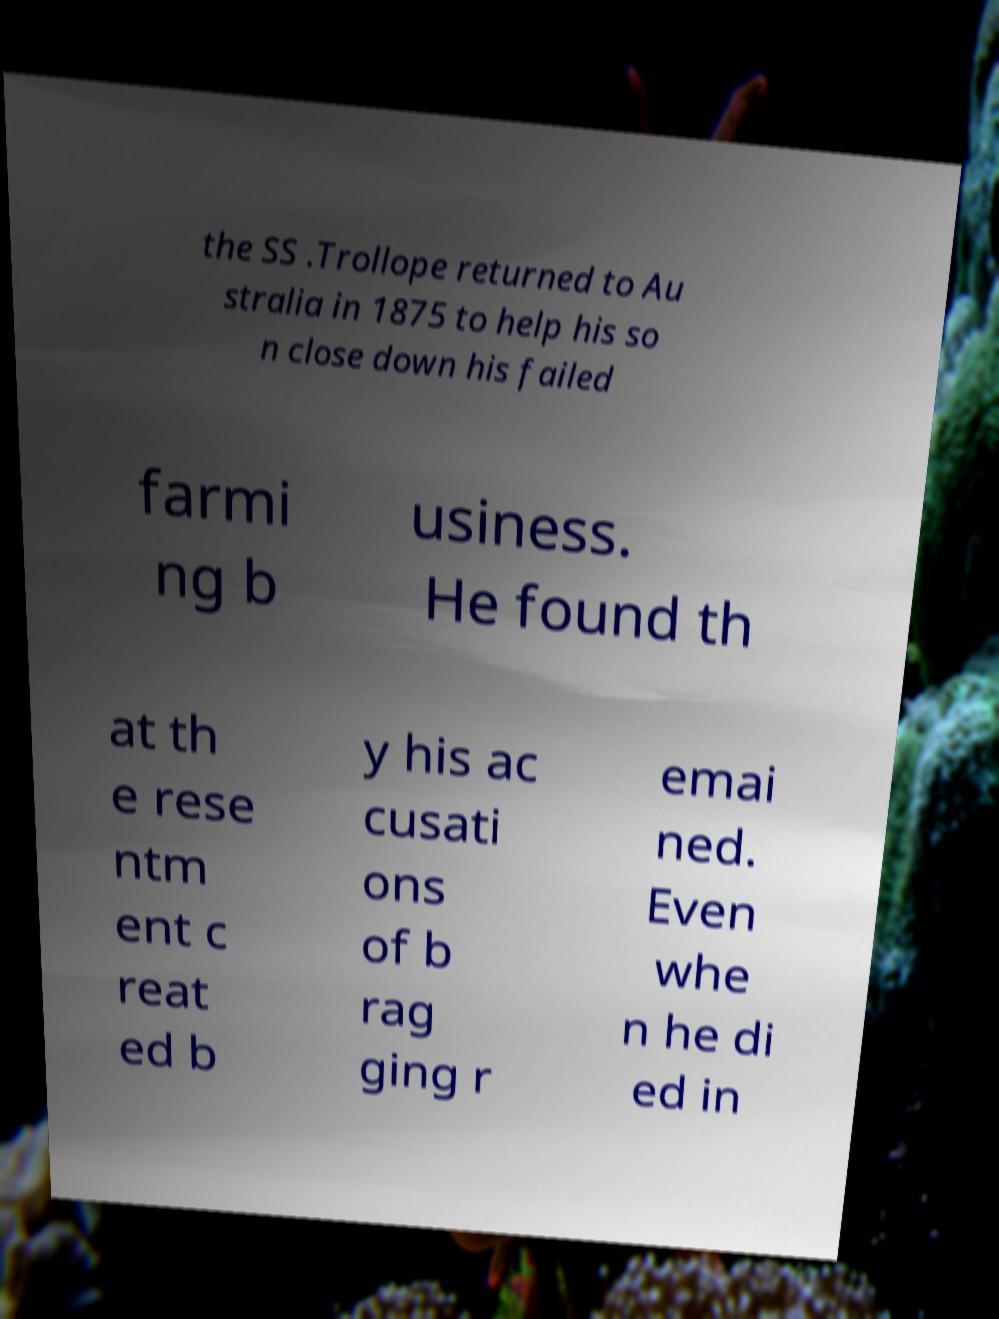Can you read and provide the text displayed in the image?This photo seems to have some interesting text. Can you extract and type it out for me? the SS .Trollope returned to Au stralia in 1875 to help his so n close down his failed farmi ng b usiness. He found th at th e rese ntm ent c reat ed b y his ac cusati ons of b rag ging r emai ned. Even whe n he di ed in 